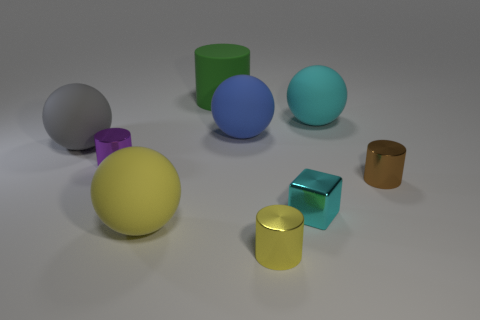Subtract all red cylinders. Subtract all green blocks. How many cylinders are left? 4 Add 1 large rubber objects. How many objects exist? 10 Subtract all spheres. How many objects are left? 5 Add 5 yellow things. How many yellow things exist? 7 Subtract 1 cyan cubes. How many objects are left? 8 Subtract all big gray shiny balls. Subtract all yellow rubber spheres. How many objects are left? 8 Add 9 gray spheres. How many gray spheres are left? 10 